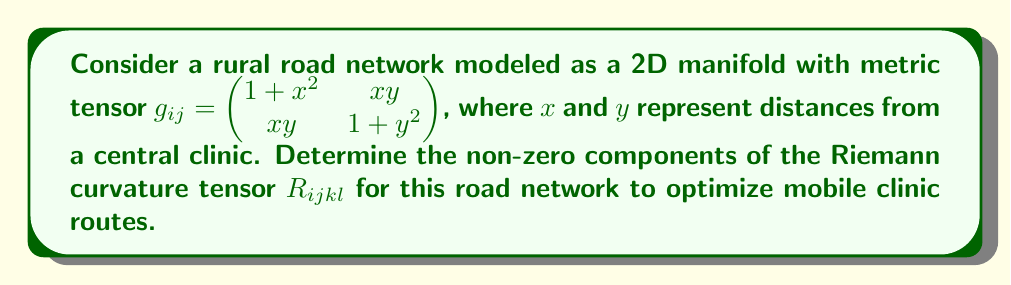Provide a solution to this math problem. To find the Riemann curvature tensor, we'll follow these steps:

1) First, calculate the Christoffel symbols $\Gamma^i_{jk}$:
   $$\Gamma^i_{jk} = \frac{1}{2}g^{im}(\partial_j g_{mk} + \partial_k g_{mj} - \partial_m g_{jk})$$

2) The inverse metric tensor $g^{ij}$ is:
   $$g^{ij} = \frac{1}{(1+x^2)(1+y^2)-x^2y^2} \begin{pmatrix} 1+y^2 & -xy \\ -xy & 1+x^2 \end{pmatrix}$$

3) Calculate the non-zero Christoffel symbols:
   $$\Gamma^1_{11} = \frac{x(1+y^2)}{(1+x^2)(1+y^2)-x^2y^2}$$
   $$\Gamma^1_{12} = \Gamma^1_{21} = \frac{y(1+y^2)}{(1+x^2)(1+y^2)-x^2y^2}$$
   $$\Gamma^1_{22} = -\frac{xy}{(1+x^2)(1+y^2)-x^2y^2}$$
   $$\Gamma^2_{11} = -\frac{xy}{(1+x^2)(1+y^2)-x^2y^2}$$
   $$\Gamma^2_{12} = \Gamma^2_{21} = \frac{x(1+x^2)}{(1+x^2)(1+y^2)-x^2y^2}$$
   $$\Gamma^2_{22} = \frac{y(1+x^2)}{(1+x^2)(1+y^2)-x^2y^2}$$

4) The Riemann curvature tensor is given by:
   $$R^i_{jkl} = \partial_k \Gamma^i_{jl} - \partial_l \Gamma^i_{jk} + \Gamma^m_{jl}\Gamma^i_{mk} - \Gamma^m_{jk}\Gamma^i_{ml}$$

5) Calculate the non-zero components:
   $$R^1_{212} = -R^1_{221} = \frac{x^2+y^2+3}{((1+x^2)(1+y^2)-x^2y^2)^2}$$
   $$R^2_{121} = -R^2_{112} = \frac{x^2+y^2+3}{((1+x^2)(1+y^2)-x^2y^2)^2}$$

6) Lower the first index to get $R_{ijkl}$:
   $$R_{1212} = -R_{1221} = R_{2121} = -R_{2112} = \frac{x^2+y^2+3}{(1+x^2)(1+y^2)-x^2y^2}$$

These are the non-zero components of the Riemann curvature tensor for the given road network.
Answer: $R_{1212} = -R_{1221} = R_{2121} = -R_{2112} = \frac{x^2+y^2+3}{(1+x^2)(1+y^2)-x^2y^2}$ 